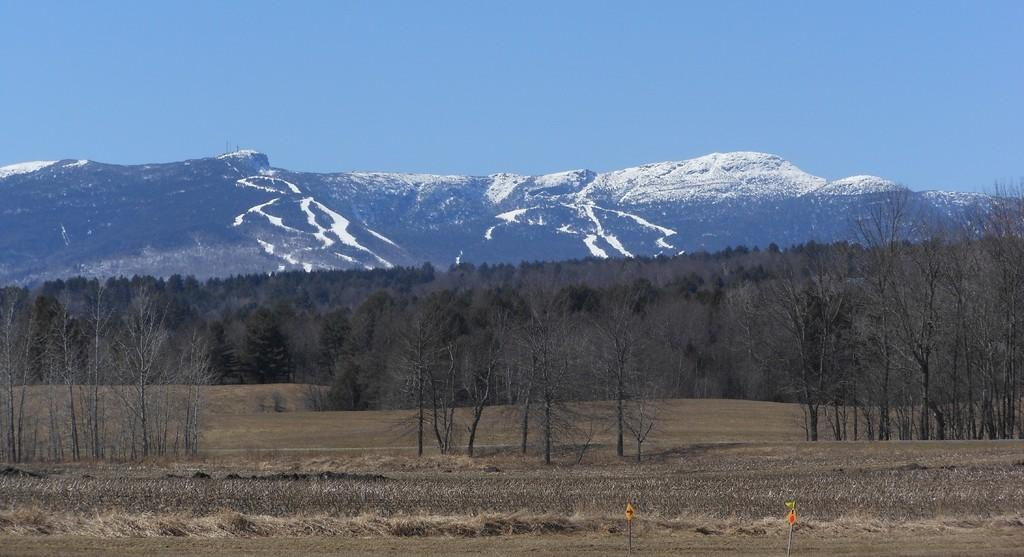What type of natural environment is depicted in the image? The image features trees and mountains. Can you describe the landscape in the image? The landscape includes trees and mountains. Where can the cherries be found in the image? There are no cherries present in the image. What type of fiction is being depicted in the image? The image does not depict any type of fiction; it features trees and mountains in a natural landscape. 